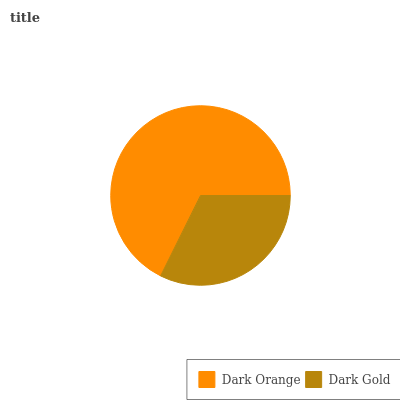Is Dark Gold the minimum?
Answer yes or no. Yes. Is Dark Orange the maximum?
Answer yes or no. Yes. Is Dark Gold the maximum?
Answer yes or no. No. Is Dark Orange greater than Dark Gold?
Answer yes or no. Yes. Is Dark Gold less than Dark Orange?
Answer yes or no. Yes. Is Dark Gold greater than Dark Orange?
Answer yes or no. No. Is Dark Orange less than Dark Gold?
Answer yes or no. No. Is Dark Orange the high median?
Answer yes or no. Yes. Is Dark Gold the low median?
Answer yes or no. Yes. Is Dark Gold the high median?
Answer yes or no. No. Is Dark Orange the low median?
Answer yes or no. No. 